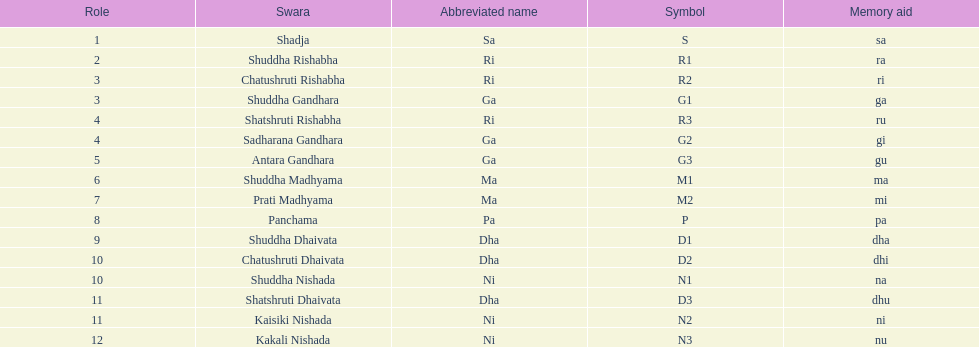What is the appellation of the swara succeeding panchama? Shuddha Dhaivata. 